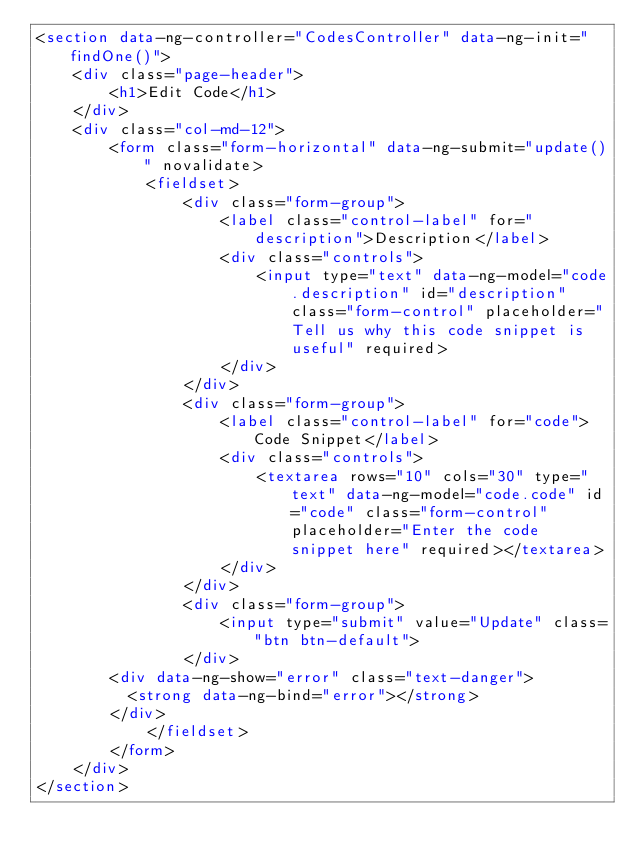Convert code to text. <code><loc_0><loc_0><loc_500><loc_500><_HTML_><section data-ng-controller="CodesController" data-ng-init="findOne()">
    <div class="page-header">
        <h1>Edit Code</h1>
    </div>
    <div class="col-md-12">
        <form class="form-horizontal" data-ng-submit="update()" novalidate>
            <fieldset>
                <div class="form-group">
                    <label class="control-label" for="description">Description</label>
                    <div class="controls">
                        <input type="text" data-ng-model="code.description" id="description" class="form-control" placeholder="Tell us why this code snippet is useful" required>
                    </div>
                </div>
                <div class="form-group">
                    <label class="control-label" for="code">Code Snippet</label>
                    <div class="controls">
                        <textarea rows="10" cols="30" type="text" data-ng-model="code.code" id="code" class="form-control" placeholder="Enter the code snippet here" required></textarea>
                    </div>
                </div>
                <div class="form-group">
                    <input type="submit" value="Update" class="btn btn-default">
                </div>
				<div data-ng-show="error" class="text-danger">
					<strong data-ng-bind="error"></strong>
				</div>
            </fieldset>
        </form>
    </div>
</section>


</code> 